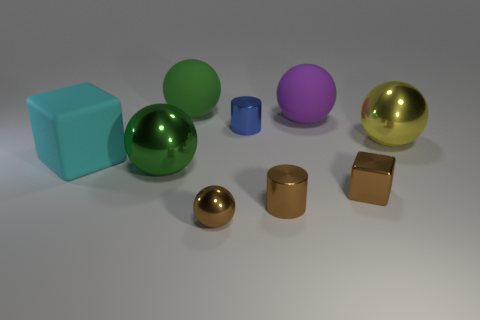There is a large rubber object in front of the yellow object that is in front of the small cylinder behind the cyan block; what shape is it?
Provide a succinct answer. Cube. What number of blue things are either matte blocks or matte things?
Your answer should be very brief. 0. Are there an equal number of large rubber spheres that are on the right side of the large purple matte ball and green metal spheres that are to the right of the large yellow shiny sphere?
Give a very brief answer. Yes. There is a brown metal thing to the right of the purple thing; is it the same shape as the green object in front of the cyan rubber block?
Offer a terse response. No. Is there any other thing that is the same shape as the large cyan matte thing?
Your answer should be compact. Yes. The green thing that is the same material as the big cyan object is what shape?
Provide a succinct answer. Sphere. Are there the same number of big green spheres that are in front of the big purple matte sphere and small yellow rubber blocks?
Your answer should be very brief. No. Are the green sphere that is behind the purple rubber thing and the tiny object that is behind the metal block made of the same material?
Your answer should be very brief. No. There is a small object that is behind the small brown shiny object right of the brown metallic cylinder; what is its shape?
Offer a terse response. Cylinder. What is the color of the other sphere that is made of the same material as the purple ball?
Offer a very short reply. Green. 